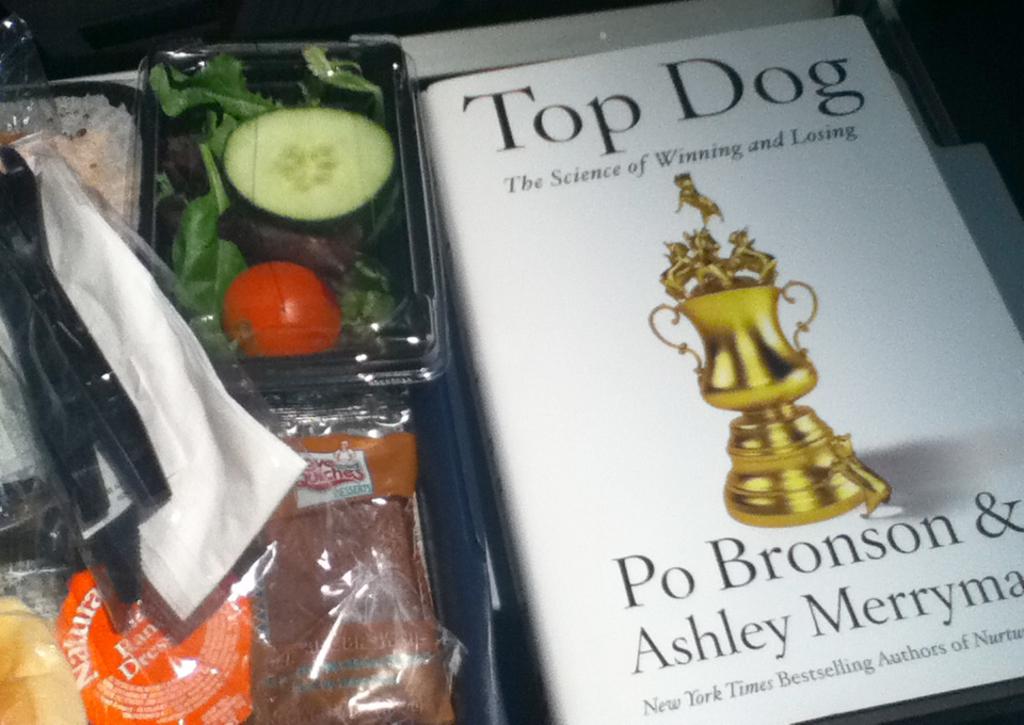What is the byline for this book?
Your answer should be compact. The science of winning and losing. Who wrote this book?
Make the answer very short. Po bronson & ashley merryman. 